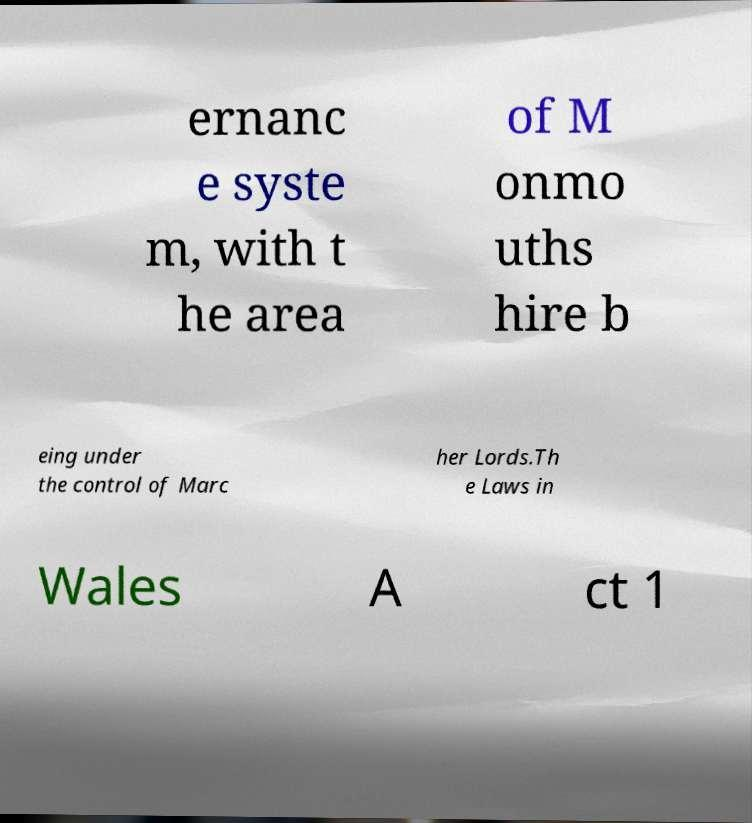There's text embedded in this image that I need extracted. Can you transcribe it verbatim? ernanc e syste m, with t he area of M onmo uths hire b eing under the control of Marc her Lords.Th e Laws in Wales A ct 1 